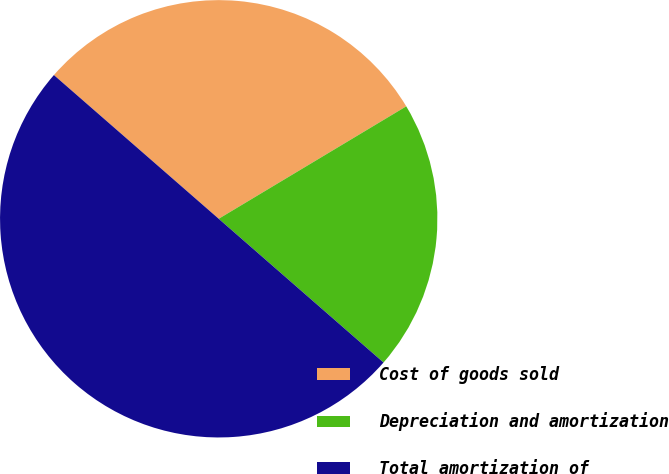<chart> <loc_0><loc_0><loc_500><loc_500><pie_chart><fcel>Cost of goods sold<fcel>Depreciation and amortization<fcel>Total amortization of<nl><fcel>29.99%<fcel>20.01%<fcel>50.0%<nl></chart> 